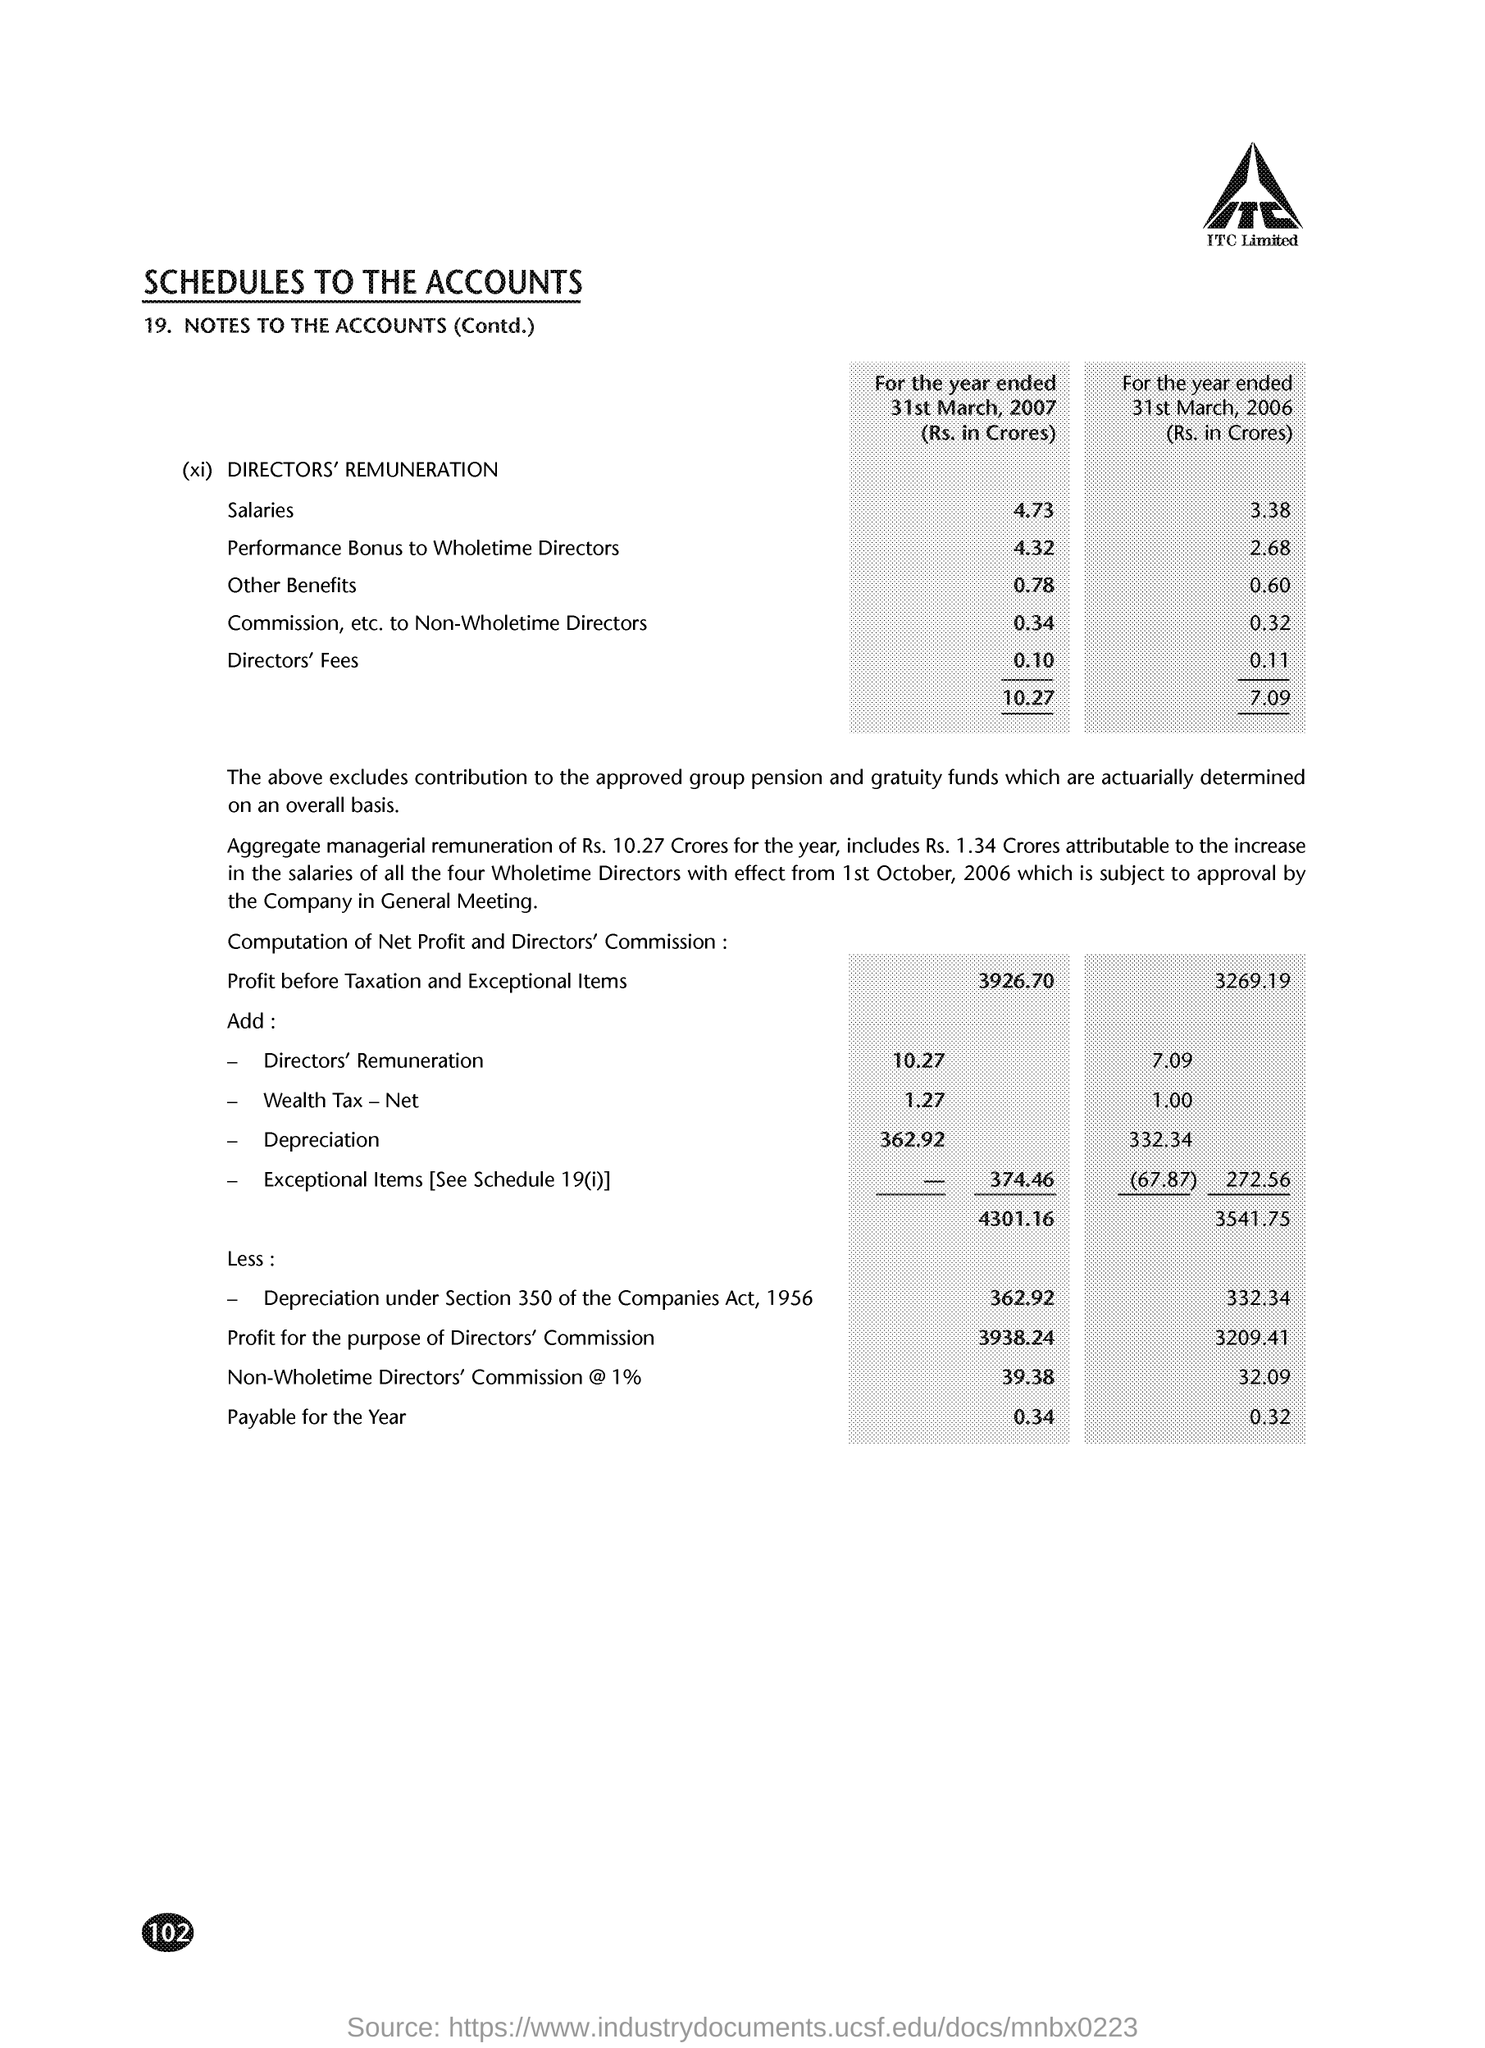Indicate a few pertinent items in this graphic. The salaries for the year ended on March 31, 2006 were Rs. 3.38 crores. 